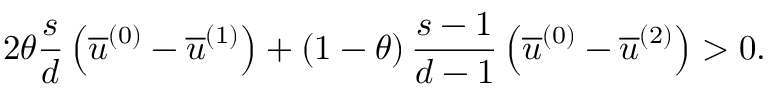Convert formula to latex. <formula><loc_0><loc_0><loc_500><loc_500>2 \theta \frac { s } { d } \left ( \overline { u } ^ { \left ( 0 \right ) } - \overline { u } ^ { \left ( 1 \right ) } \right ) + \left ( 1 - \theta \right ) \frac { s - 1 } { d - 1 } \left ( \overline { u } ^ { \left ( 0 \right ) } - \overline { u } ^ { \left ( 2 \right ) } \right ) > 0 .</formula> 